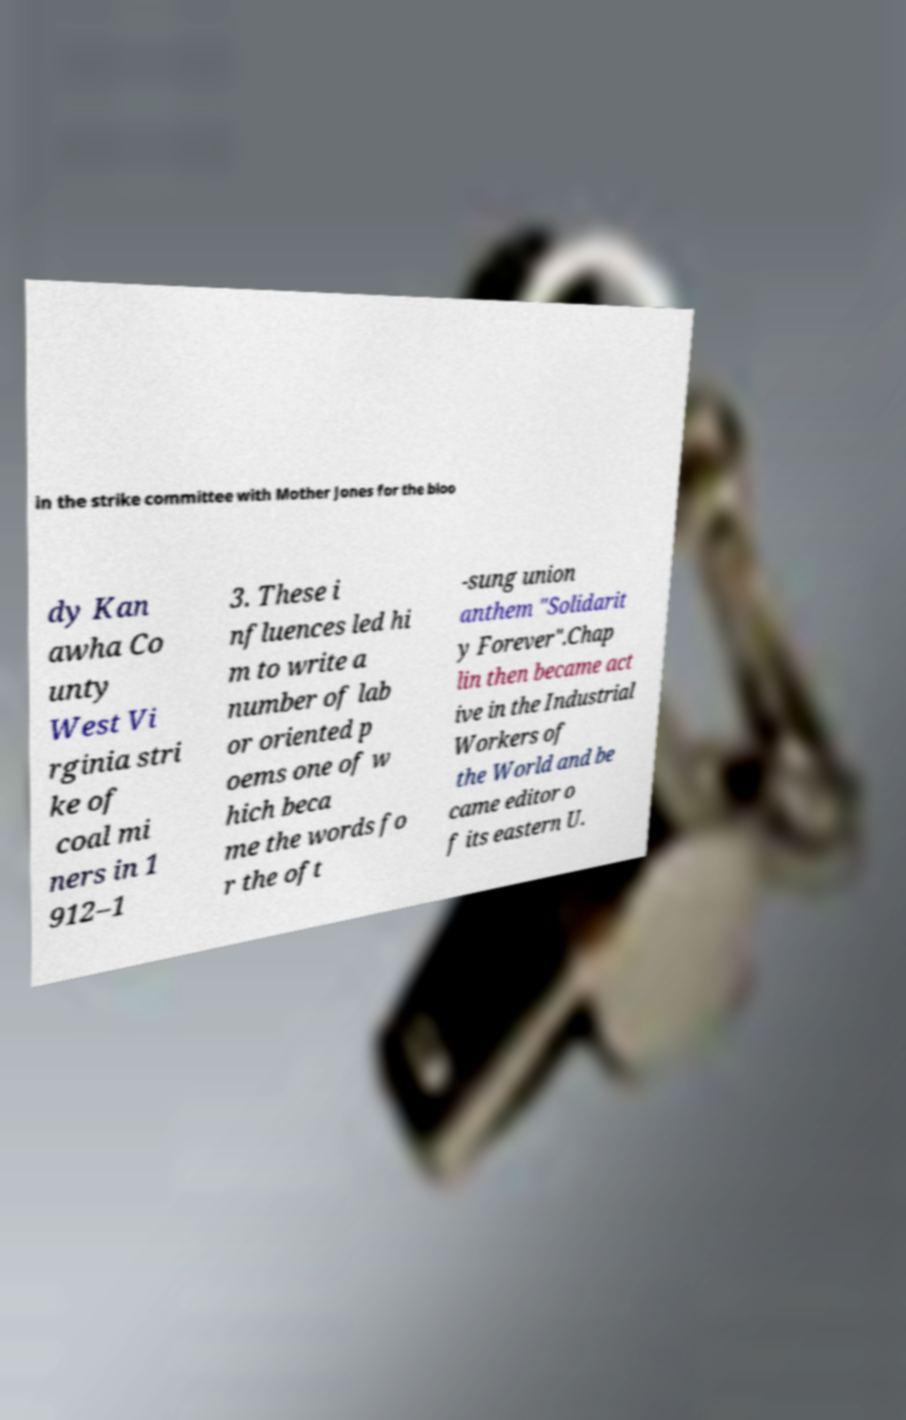I need the written content from this picture converted into text. Can you do that? in the strike committee with Mother Jones for the bloo dy Kan awha Co unty West Vi rginia stri ke of coal mi ners in 1 912–1 3. These i nfluences led hi m to write a number of lab or oriented p oems one of w hich beca me the words fo r the oft -sung union anthem "Solidarit y Forever".Chap lin then became act ive in the Industrial Workers of the World and be came editor o f its eastern U. 